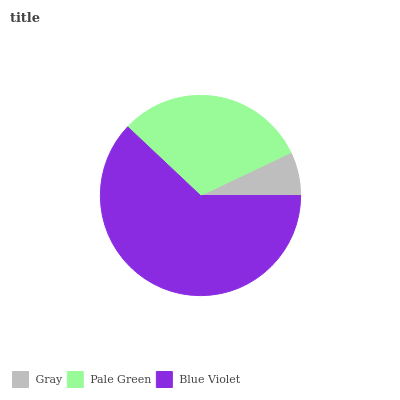Is Gray the minimum?
Answer yes or no. Yes. Is Blue Violet the maximum?
Answer yes or no. Yes. Is Pale Green the minimum?
Answer yes or no. No. Is Pale Green the maximum?
Answer yes or no. No. Is Pale Green greater than Gray?
Answer yes or no. Yes. Is Gray less than Pale Green?
Answer yes or no. Yes. Is Gray greater than Pale Green?
Answer yes or no. No. Is Pale Green less than Gray?
Answer yes or no. No. Is Pale Green the high median?
Answer yes or no. Yes. Is Pale Green the low median?
Answer yes or no. Yes. Is Gray the high median?
Answer yes or no. No. Is Blue Violet the low median?
Answer yes or no. No. 